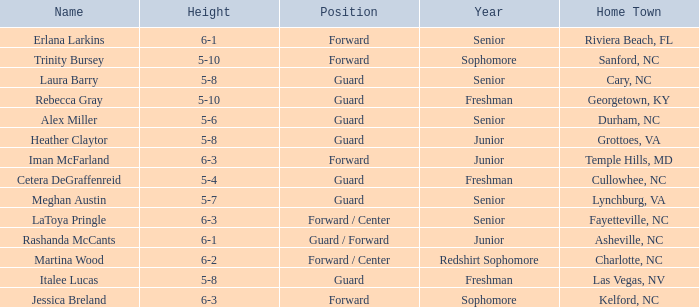What role does the 5-8 athlete from grottoes, va perform? Guard. 